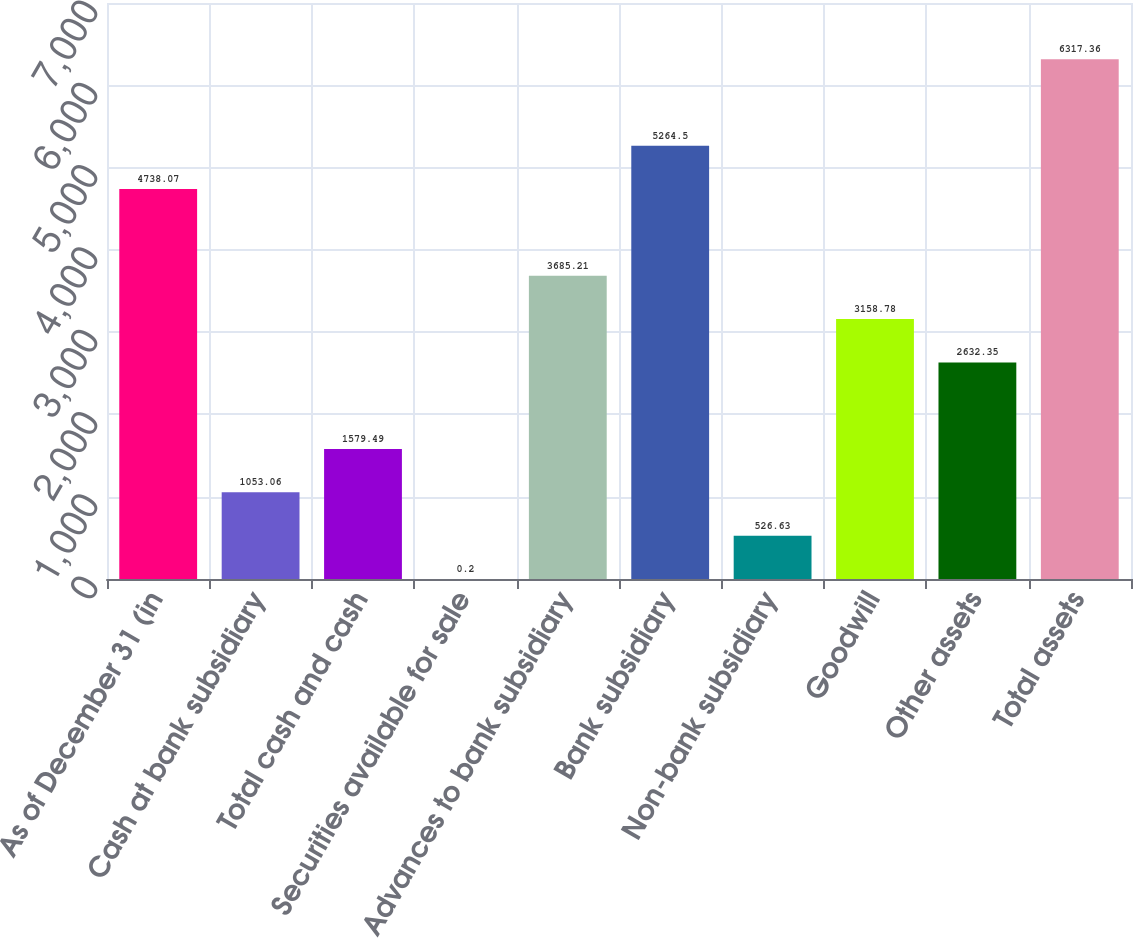Convert chart. <chart><loc_0><loc_0><loc_500><loc_500><bar_chart><fcel>As of December 31 (in<fcel>Cash at bank subsidiary<fcel>Total cash and cash<fcel>Securities available for sale<fcel>Advances to bank subsidiary<fcel>Bank subsidiary<fcel>Non-bank subsidiary<fcel>Goodwill<fcel>Other assets<fcel>Total assets<nl><fcel>4738.07<fcel>1053.06<fcel>1579.49<fcel>0.2<fcel>3685.21<fcel>5264.5<fcel>526.63<fcel>3158.78<fcel>2632.35<fcel>6317.36<nl></chart> 